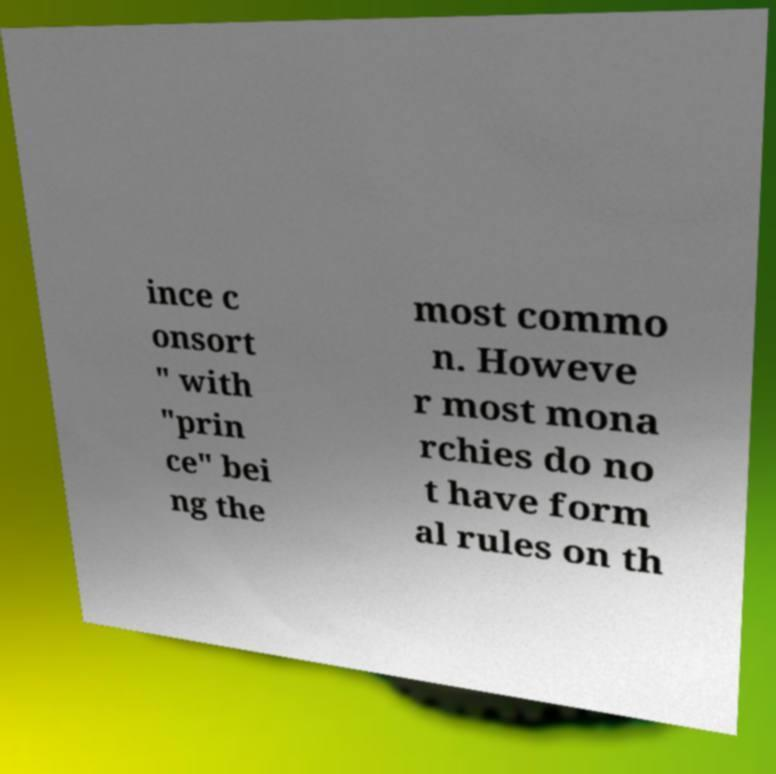Please identify and transcribe the text found in this image. ince c onsort " with "prin ce" bei ng the most commo n. Howeve r most mona rchies do no t have form al rules on th 